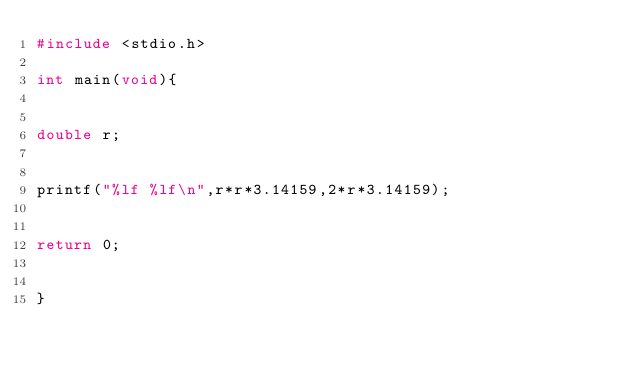Convert code to text. <code><loc_0><loc_0><loc_500><loc_500><_C_>#include <stdio.h>

int main(void){


double r;


printf("%lf %lf\n",r*r*3.14159,2*r*3.14159);


return 0;


}</code> 